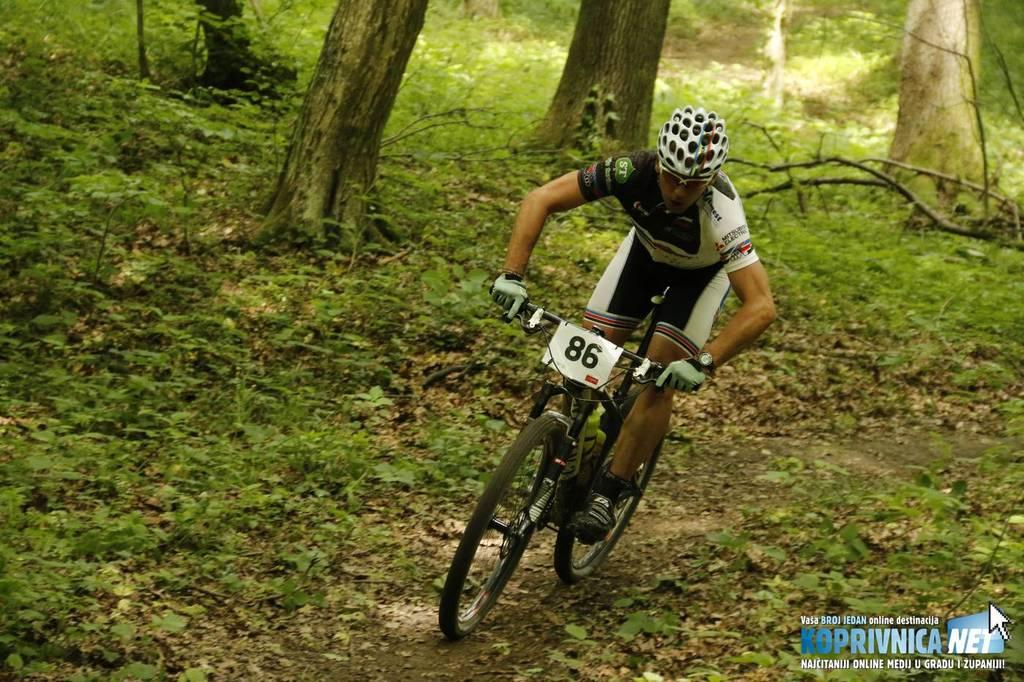What is the main subject of the image? There is a person in the image. What is the person doing in the image? The person is riding a cycle. What can be seen in the background of the image? There are trees in the background of the image. Is there any text or label present in the image? Yes, the name of something (possibly the person or the location) is present in the bottom right-hand side of the image. What type of scissors can be seen in the image? There are no scissors present in the image. How does the person sneeze while riding the cycle in the image? The person is not sneezing in the image; they are riding the cycle. 